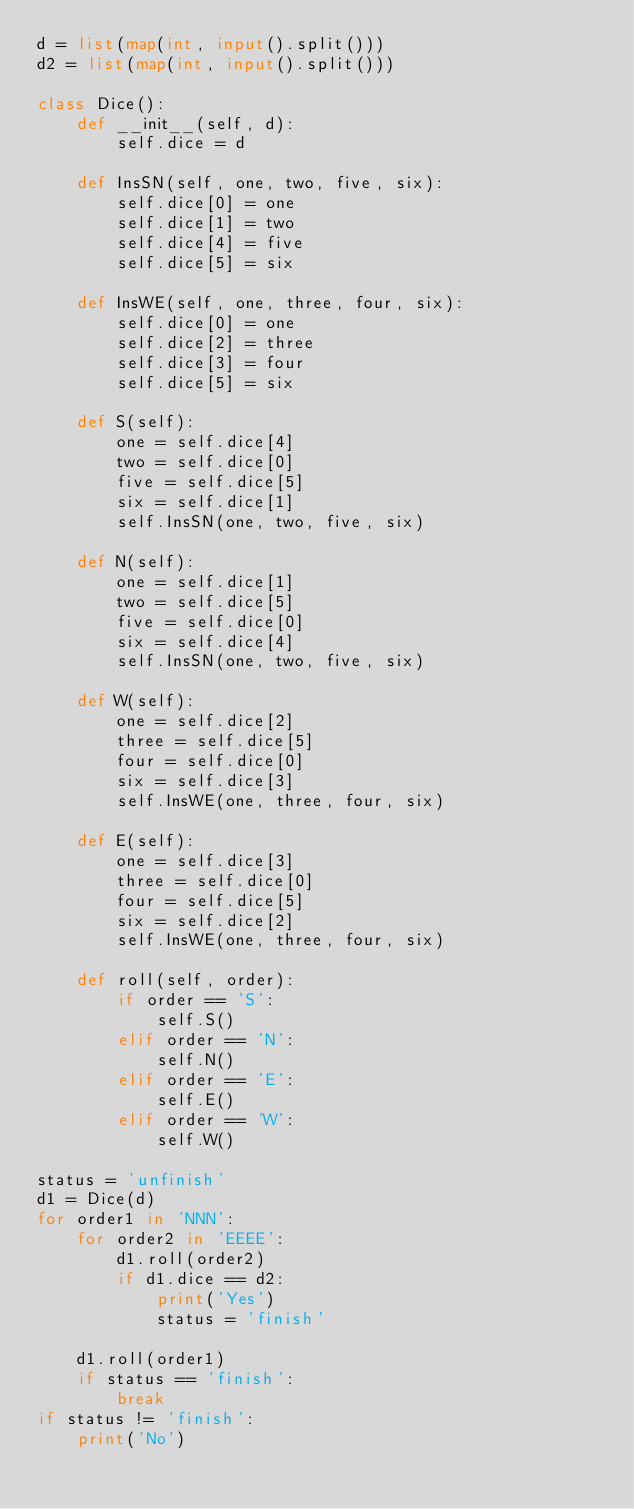<code> <loc_0><loc_0><loc_500><loc_500><_Python_>d = list(map(int, input().split()))
d2 = list(map(int, input().split()))

class Dice():
    def __init__(self, d):
        self.dice = d

    def InsSN(self, one, two, five, six):
        self.dice[0] = one
        self.dice[1] = two
        self.dice[4] = five
        self.dice[5] = six
        
    def InsWE(self, one, three, four, six):
        self.dice[0] = one
        self.dice[2] = three
        self.dice[3] = four
        self.dice[5] = six

    def S(self):
        one = self.dice[4]
        two = self.dice[0]
        five = self.dice[5]
        six = self.dice[1]
        self.InsSN(one, two, five, six)

    def N(self):
        one = self.dice[1]
        two = self.dice[5]
        five = self.dice[0]
        six = self.dice[4]
        self.InsSN(one, two, five, six)
 
    def W(self):
        one = self.dice[2]
        three = self.dice[5]
        four = self.dice[0]
        six = self.dice[3]
        self.InsWE(one, three, four, six)
        
    def E(self):
        one = self.dice[3]
        three = self.dice[0]
        four = self.dice[5]
        six = self.dice[2]
        self.InsWE(one, three, four, six)
        
    def roll(self, order):
        if order == 'S':
            self.S()
        elif order == 'N':
            self.N()
        elif order == 'E':
            self.E()
        elif order == 'W':
            self.W()

status = 'unfinish'
d1 = Dice(d)
for order1 in 'NNN':
    for order2 in 'EEEE':
        d1.roll(order2)
        if d1.dice == d2:
            print('Yes')
            status = 'finish'

    d1.roll(order1)
    if status == 'finish':
        break
if status != 'finish':
    print('No')</code> 